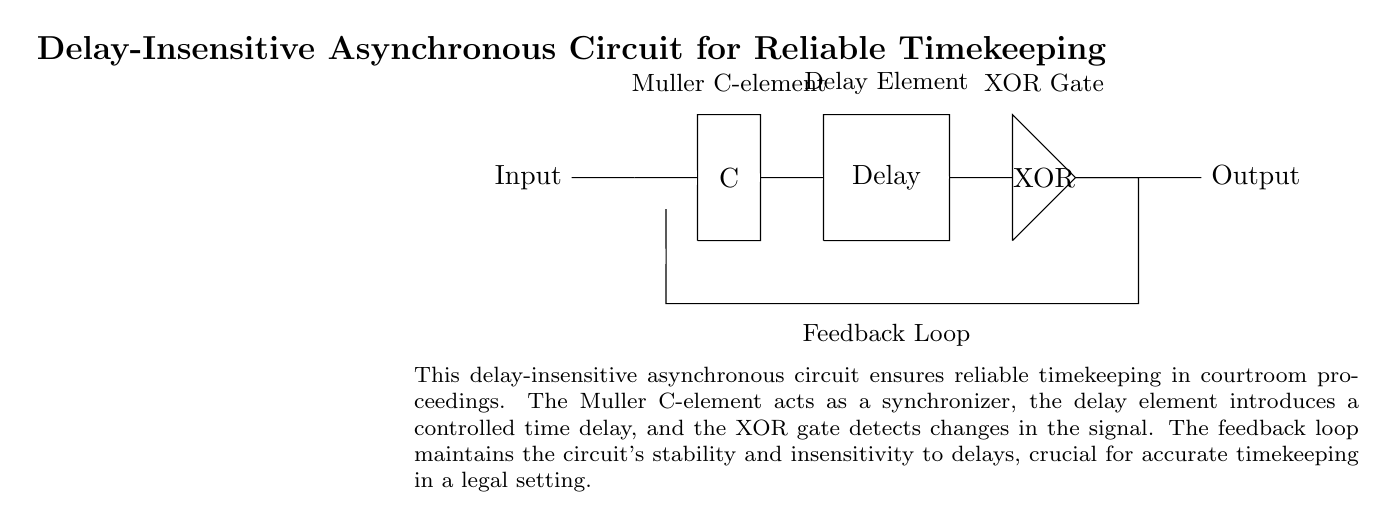What is the first component in the circuit? The first component in the circuit, as indicated at the top, is the Input, which represents the initial signal for the system.
Answer: Input What type of logic component is represented by the symbol labeled "C"? The "C" represents a Muller C-element, which is a type of asynchronous logic gate used for synchronization in the circuit.
Answer: Muller C-element What is the function of the delay element in this circuit? The delay element introduces a controlled time delay to ensure that the signals have settled before further processing, which is crucial for reliable timekeeping.
Answer: Time delay How many gates are used in this circuit? There are two types of gates used: one Muller C-element and one XOR gate, giving a total of two gates.
Answer: Two What maintains the circuit's stability during operation? The feedback loop, as indicated in the diagram, maintains the stability of the circuit by preventing oscillations and ensuring consistency in operation.
Answer: Feedback loop Why is the circuit described as "delay-insensitive"? The term "delay-insensitive" indicates that the circuit can function correctly regardless of variations in signal delay, owing to the design of the Muller C-element and feedback loop.
Answer: Delay-insensitive 